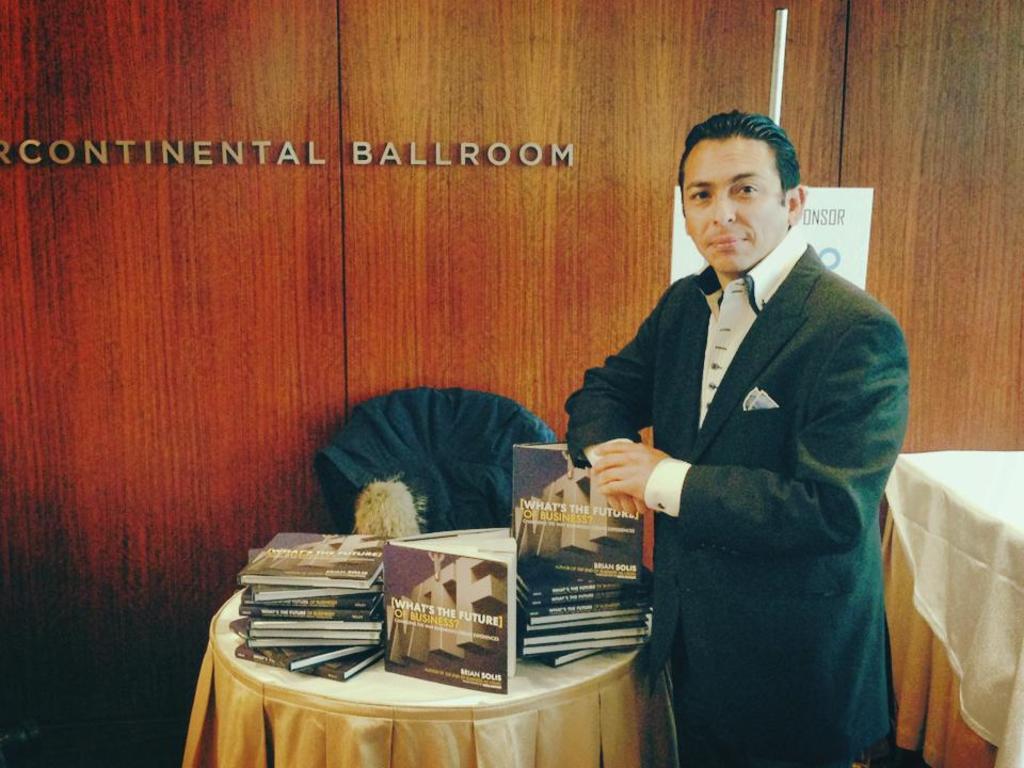Which ballroom is the man standing in?
Offer a terse response. Continental ballroom. Is the text all in capital letters?
Give a very brief answer. Yes. 